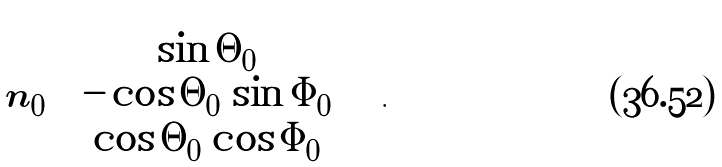Convert formula to latex. <formula><loc_0><loc_0><loc_500><loc_500>\boldsymbol n _ { 0 } \begin{pmatrix} \sin \Theta _ { 0 } \\ - \cos \Theta _ { 0 } \, \sin \Phi _ { 0 } \\ \cos \Theta _ { 0 } \, \cos \Phi _ { 0 } \end{pmatrix} \text { .}</formula> 